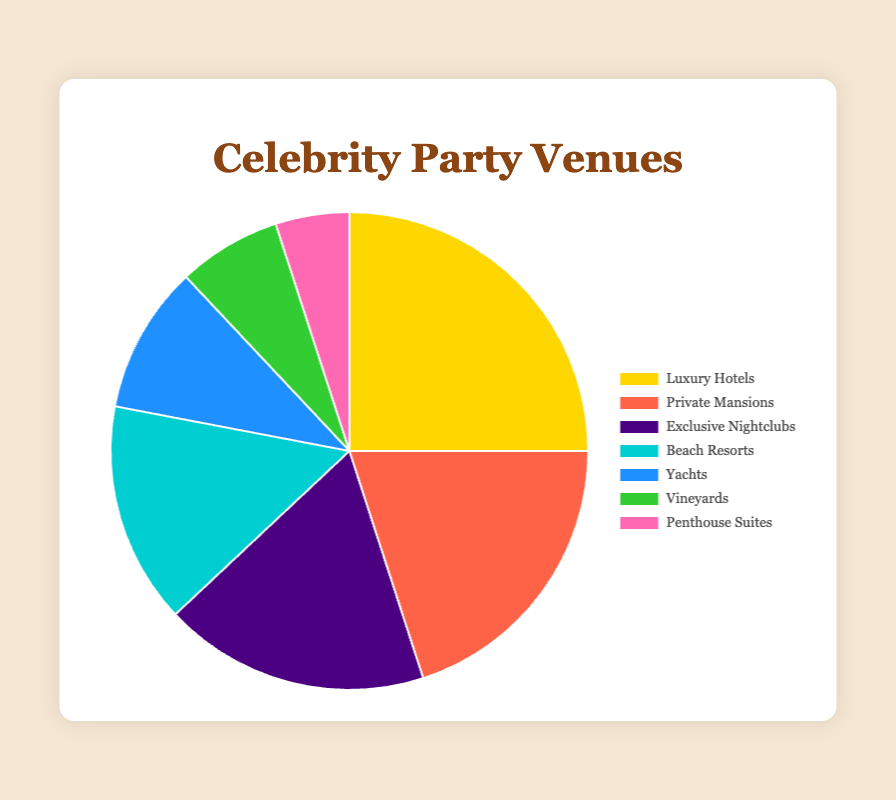Which venue category is most favored by celebrities for hosting parties? The largest portion of the pie chart represents "Luxury Hotels," which makes up 25% of the total.
Answer: Luxury Hotels Which two categories combined make up nearly 50% of the venues? Luxury Hotels (25%) and Private Mansions (20%) together account for 45%.
Answer: Luxury Hotels and Private Mansions How much more popular are Luxury Hotels compared to Yachts? Luxury Hotels are at 25% while Yachts are at 10%, so Luxury Hotels are 25% - 10% = 15% more popular.
Answer: 15% If you sum the percentages of Exclusive Nightclubs, Beach Resorts, and Vineyards, what do you get? Exclusive Nightclubs (18%), Beach Resorts (15%), and Vineyards (7%) together make 18% + 15% + 7% = 40%.
Answer: 40% Are Beach Resorts more favored than Yachts? Beach Resorts have 15% while Yachts have 10%, making Beach Resorts more favored.
Answer: Yes Which venue category has the smallest portion represented in the pie chart? The smallest portion in the pie chart is the "Penthouse Suites" at 5%.
Answer: Penthouse Suites If the percentages for Luxury Hotels and Private Mansions were reversed, what would the new percentage for Private Mansions be? If reversed, the percentage for Private Mansions would be 25% while Luxury Hotels would become 20%.
Answer: 25% How does the popularity of Exclusive Nightclubs compare to that of Beach Resorts? Which is more favored and by how much? Exclusive Nightclubs are at 18% and Beach Resorts are at 15%. So, Exclusive Nightclubs are more favored by 18% - 15% = 3%.
Answer: Exclusive Nightclubs by 3% What percentage of the total is made up by venues other than Luxury Hotels and Private Mansions? The total percentage is 100%. Subtracting the percentages for Luxury Hotels (25%) and Private Mansions (20%) leaves 100% - 25% - 20% = 55%.
Answer: 55% What is the combined popularity of Yachts and Penthouse Suites, and how does it compare to the popularity of Exclusive Nightclubs? Yachts (10%) and Penthouse Suites (5%) combined account for 10% + 5% = 15%. Exclusive Nightclubs are at 18%, so Exclusive Nightclubs are more popular by 18% - 15% = 3%.
Answer: 15%, Exclusive Nightclubs by 3% 